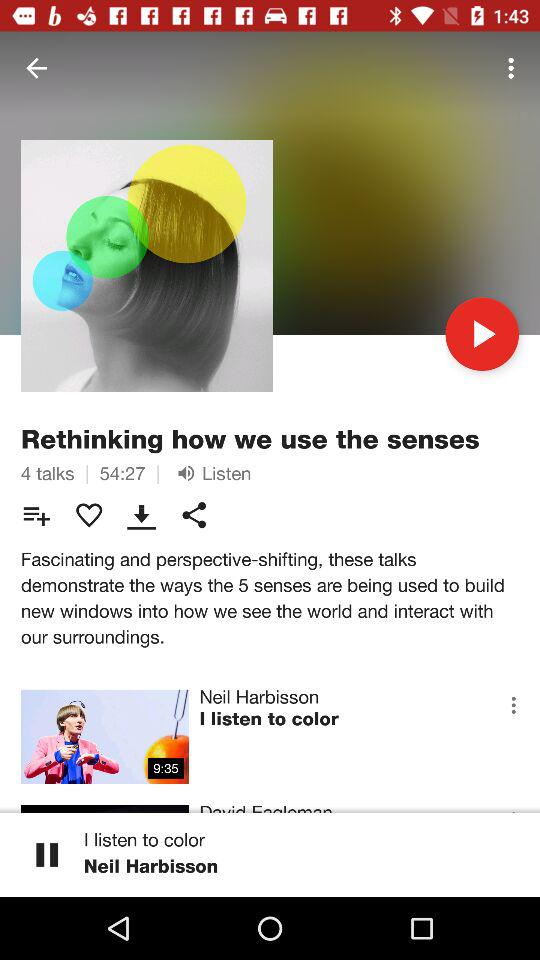How many talks are in "Rethinking"? There are 4 talks in "Rethinking". 